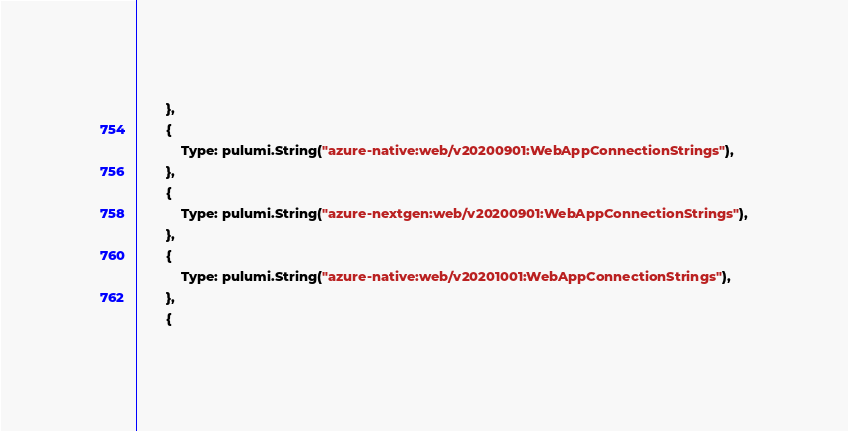Convert code to text. <code><loc_0><loc_0><loc_500><loc_500><_Go_>		},
		{
			Type: pulumi.String("azure-native:web/v20200901:WebAppConnectionStrings"),
		},
		{
			Type: pulumi.String("azure-nextgen:web/v20200901:WebAppConnectionStrings"),
		},
		{
			Type: pulumi.String("azure-native:web/v20201001:WebAppConnectionStrings"),
		},
		{</code> 